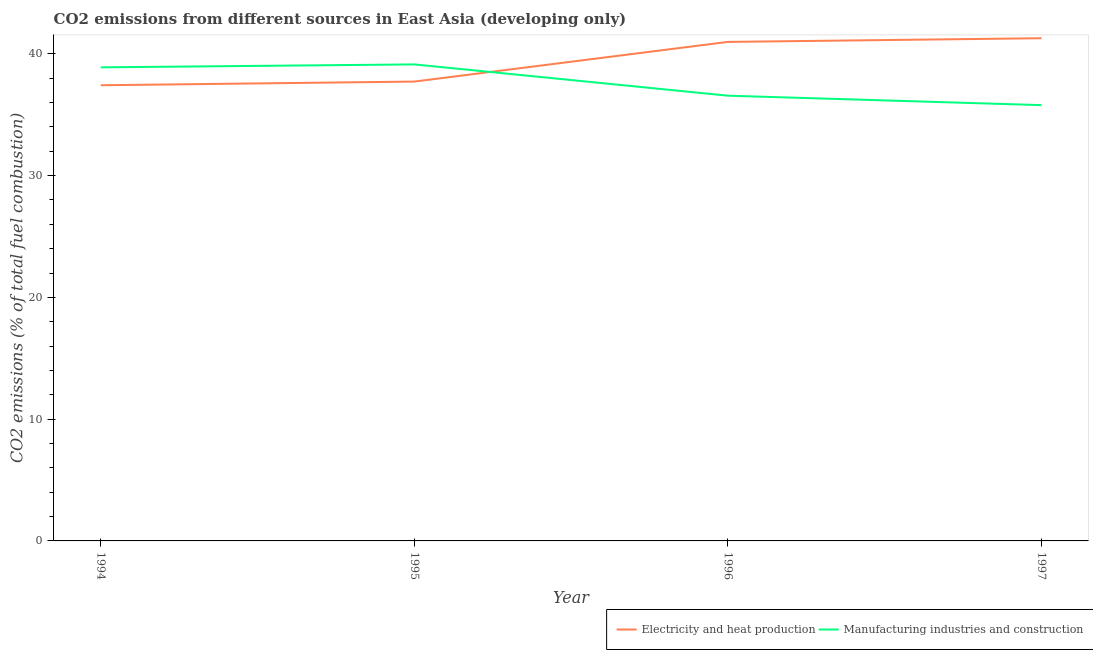Does the line corresponding to co2 emissions due to manufacturing industries intersect with the line corresponding to co2 emissions due to electricity and heat production?
Provide a short and direct response. Yes. Is the number of lines equal to the number of legend labels?
Your answer should be very brief. Yes. What is the co2 emissions due to manufacturing industries in 1997?
Offer a terse response. 35.79. Across all years, what is the maximum co2 emissions due to electricity and heat production?
Provide a short and direct response. 41.28. Across all years, what is the minimum co2 emissions due to manufacturing industries?
Make the answer very short. 35.79. In which year was the co2 emissions due to electricity and heat production maximum?
Your answer should be very brief. 1997. In which year was the co2 emissions due to manufacturing industries minimum?
Your answer should be very brief. 1997. What is the total co2 emissions due to electricity and heat production in the graph?
Offer a terse response. 157.41. What is the difference between the co2 emissions due to electricity and heat production in 1994 and that in 1996?
Your answer should be compact. -3.56. What is the difference between the co2 emissions due to electricity and heat production in 1994 and the co2 emissions due to manufacturing industries in 1996?
Provide a short and direct response. 0.86. What is the average co2 emissions due to manufacturing industries per year?
Your response must be concise. 37.59. In the year 1995, what is the difference between the co2 emissions due to manufacturing industries and co2 emissions due to electricity and heat production?
Give a very brief answer. 1.41. What is the ratio of the co2 emissions due to electricity and heat production in 1994 to that in 1995?
Ensure brevity in your answer.  0.99. What is the difference between the highest and the second highest co2 emissions due to electricity and heat production?
Your answer should be compact. 0.3. What is the difference between the highest and the lowest co2 emissions due to electricity and heat production?
Ensure brevity in your answer.  3.86. In how many years, is the co2 emissions due to electricity and heat production greater than the average co2 emissions due to electricity and heat production taken over all years?
Your response must be concise. 2. How many lines are there?
Offer a very short reply. 2. Are the values on the major ticks of Y-axis written in scientific E-notation?
Your answer should be compact. No. What is the title of the graph?
Ensure brevity in your answer.  CO2 emissions from different sources in East Asia (developing only). Does "Mineral" appear as one of the legend labels in the graph?
Your answer should be very brief. No. What is the label or title of the Y-axis?
Offer a terse response. CO2 emissions (% of total fuel combustion). What is the CO2 emissions (% of total fuel combustion) of Electricity and heat production in 1994?
Ensure brevity in your answer.  37.42. What is the CO2 emissions (% of total fuel combustion) in Manufacturing industries and construction in 1994?
Your response must be concise. 38.89. What is the CO2 emissions (% of total fuel combustion) in Electricity and heat production in 1995?
Make the answer very short. 37.72. What is the CO2 emissions (% of total fuel combustion) of Manufacturing industries and construction in 1995?
Offer a very short reply. 39.13. What is the CO2 emissions (% of total fuel combustion) of Electricity and heat production in 1996?
Make the answer very short. 40.98. What is the CO2 emissions (% of total fuel combustion) of Manufacturing industries and construction in 1996?
Offer a very short reply. 36.56. What is the CO2 emissions (% of total fuel combustion) of Electricity and heat production in 1997?
Ensure brevity in your answer.  41.28. What is the CO2 emissions (% of total fuel combustion) of Manufacturing industries and construction in 1997?
Provide a short and direct response. 35.79. Across all years, what is the maximum CO2 emissions (% of total fuel combustion) in Electricity and heat production?
Your response must be concise. 41.28. Across all years, what is the maximum CO2 emissions (% of total fuel combustion) of Manufacturing industries and construction?
Keep it short and to the point. 39.13. Across all years, what is the minimum CO2 emissions (% of total fuel combustion) in Electricity and heat production?
Keep it short and to the point. 37.42. Across all years, what is the minimum CO2 emissions (% of total fuel combustion) of Manufacturing industries and construction?
Offer a very short reply. 35.79. What is the total CO2 emissions (% of total fuel combustion) of Electricity and heat production in the graph?
Your response must be concise. 157.41. What is the total CO2 emissions (% of total fuel combustion) in Manufacturing industries and construction in the graph?
Your answer should be very brief. 150.38. What is the difference between the CO2 emissions (% of total fuel combustion) in Electricity and heat production in 1994 and that in 1995?
Ensure brevity in your answer.  -0.3. What is the difference between the CO2 emissions (% of total fuel combustion) of Manufacturing industries and construction in 1994 and that in 1995?
Ensure brevity in your answer.  -0.24. What is the difference between the CO2 emissions (% of total fuel combustion) of Electricity and heat production in 1994 and that in 1996?
Ensure brevity in your answer.  -3.56. What is the difference between the CO2 emissions (% of total fuel combustion) of Manufacturing industries and construction in 1994 and that in 1996?
Make the answer very short. 2.33. What is the difference between the CO2 emissions (% of total fuel combustion) of Electricity and heat production in 1994 and that in 1997?
Keep it short and to the point. -3.86. What is the difference between the CO2 emissions (% of total fuel combustion) in Manufacturing industries and construction in 1994 and that in 1997?
Keep it short and to the point. 3.1. What is the difference between the CO2 emissions (% of total fuel combustion) of Electricity and heat production in 1995 and that in 1996?
Offer a very short reply. -3.26. What is the difference between the CO2 emissions (% of total fuel combustion) in Manufacturing industries and construction in 1995 and that in 1996?
Provide a short and direct response. 2.57. What is the difference between the CO2 emissions (% of total fuel combustion) of Electricity and heat production in 1995 and that in 1997?
Your answer should be very brief. -3.56. What is the difference between the CO2 emissions (% of total fuel combustion) of Manufacturing industries and construction in 1995 and that in 1997?
Provide a short and direct response. 3.35. What is the difference between the CO2 emissions (% of total fuel combustion) of Electricity and heat production in 1996 and that in 1997?
Offer a terse response. -0.3. What is the difference between the CO2 emissions (% of total fuel combustion) in Manufacturing industries and construction in 1996 and that in 1997?
Offer a very short reply. 0.78. What is the difference between the CO2 emissions (% of total fuel combustion) in Electricity and heat production in 1994 and the CO2 emissions (% of total fuel combustion) in Manufacturing industries and construction in 1995?
Provide a succinct answer. -1.71. What is the difference between the CO2 emissions (% of total fuel combustion) of Electricity and heat production in 1994 and the CO2 emissions (% of total fuel combustion) of Manufacturing industries and construction in 1996?
Ensure brevity in your answer.  0.86. What is the difference between the CO2 emissions (% of total fuel combustion) in Electricity and heat production in 1994 and the CO2 emissions (% of total fuel combustion) in Manufacturing industries and construction in 1997?
Provide a succinct answer. 1.63. What is the difference between the CO2 emissions (% of total fuel combustion) of Electricity and heat production in 1995 and the CO2 emissions (% of total fuel combustion) of Manufacturing industries and construction in 1996?
Provide a short and direct response. 1.16. What is the difference between the CO2 emissions (% of total fuel combustion) in Electricity and heat production in 1995 and the CO2 emissions (% of total fuel combustion) in Manufacturing industries and construction in 1997?
Offer a terse response. 1.94. What is the difference between the CO2 emissions (% of total fuel combustion) in Electricity and heat production in 1996 and the CO2 emissions (% of total fuel combustion) in Manufacturing industries and construction in 1997?
Give a very brief answer. 5.19. What is the average CO2 emissions (% of total fuel combustion) of Electricity and heat production per year?
Offer a terse response. 39.35. What is the average CO2 emissions (% of total fuel combustion) of Manufacturing industries and construction per year?
Offer a terse response. 37.59. In the year 1994, what is the difference between the CO2 emissions (% of total fuel combustion) of Electricity and heat production and CO2 emissions (% of total fuel combustion) of Manufacturing industries and construction?
Ensure brevity in your answer.  -1.47. In the year 1995, what is the difference between the CO2 emissions (% of total fuel combustion) of Electricity and heat production and CO2 emissions (% of total fuel combustion) of Manufacturing industries and construction?
Provide a succinct answer. -1.41. In the year 1996, what is the difference between the CO2 emissions (% of total fuel combustion) of Electricity and heat production and CO2 emissions (% of total fuel combustion) of Manufacturing industries and construction?
Your answer should be compact. 4.42. In the year 1997, what is the difference between the CO2 emissions (% of total fuel combustion) in Electricity and heat production and CO2 emissions (% of total fuel combustion) in Manufacturing industries and construction?
Your answer should be very brief. 5.5. What is the ratio of the CO2 emissions (% of total fuel combustion) in Electricity and heat production in 1994 to that in 1995?
Provide a succinct answer. 0.99. What is the ratio of the CO2 emissions (% of total fuel combustion) of Manufacturing industries and construction in 1994 to that in 1995?
Your answer should be compact. 0.99. What is the ratio of the CO2 emissions (% of total fuel combustion) of Electricity and heat production in 1994 to that in 1996?
Your response must be concise. 0.91. What is the ratio of the CO2 emissions (% of total fuel combustion) in Manufacturing industries and construction in 1994 to that in 1996?
Provide a short and direct response. 1.06. What is the ratio of the CO2 emissions (% of total fuel combustion) in Electricity and heat production in 1994 to that in 1997?
Provide a succinct answer. 0.91. What is the ratio of the CO2 emissions (% of total fuel combustion) in Manufacturing industries and construction in 1994 to that in 1997?
Offer a terse response. 1.09. What is the ratio of the CO2 emissions (% of total fuel combustion) in Electricity and heat production in 1995 to that in 1996?
Provide a short and direct response. 0.92. What is the ratio of the CO2 emissions (% of total fuel combustion) in Manufacturing industries and construction in 1995 to that in 1996?
Give a very brief answer. 1.07. What is the ratio of the CO2 emissions (% of total fuel combustion) in Electricity and heat production in 1995 to that in 1997?
Provide a short and direct response. 0.91. What is the ratio of the CO2 emissions (% of total fuel combustion) in Manufacturing industries and construction in 1995 to that in 1997?
Provide a succinct answer. 1.09. What is the ratio of the CO2 emissions (% of total fuel combustion) in Manufacturing industries and construction in 1996 to that in 1997?
Your answer should be compact. 1.02. What is the difference between the highest and the second highest CO2 emissions (% of total fuel combustion) in Electricity and heat production?
Provide a succinct answer. 0.3. What is the difference between the highest and the second highest CO2 emissions (% of total fuel combustion) of Manufacturing industries and construction?
Your response must be concise. 0.24. What is the difference between the highest and the lowest CO2 emissions (% of total fuel combustion) of Electricity and heat production?
Provide a short and direct response. 3.86. What is the difference between the highest and the lowest CO2 emissions (% of total fuel combustion) of Manufacturing industries and construction?
Offer a very short reply. 3.35. 